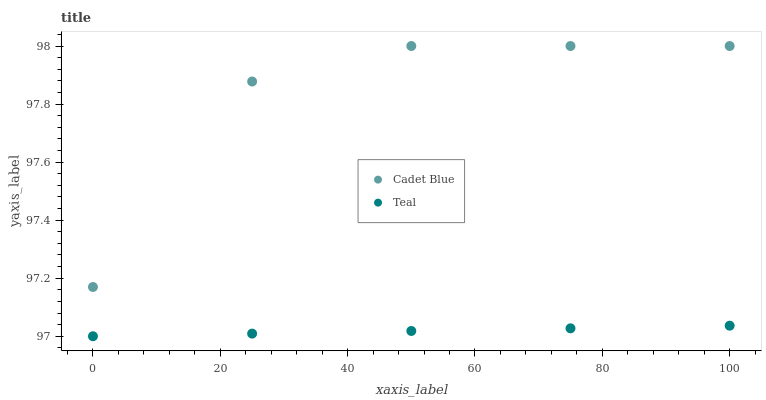Does Teal have the minimum area under the curve?
Answer yes or no. Yes. Does Cadet Blue have the maximum area under the curve?
Answer yes or no. Yes. Does Teal have the maximum area under the curve?
Answer yes or no. No. Is Teal the smoothest?
Answer yes or no. Yes. Is Cadet Blue the roughest?
Answer yes or no. Yes. Is Teal the roughest?
Answer yes or no. No. Does Teal have the lowest value?
Answer yes or no. Yes. Does Cadet Blue have the highest value?
Answer yes or no. Yes. Does Teal have the highest value?
Answer yes or no. No. Is Teal less than Cadet Blue?
Answer yes or no. Yes. Is Cadet Blue greater than Teal?
Answer yes or no. Yes. Does Teal intersect Cadet Blue?
Answer yes or no. No. 